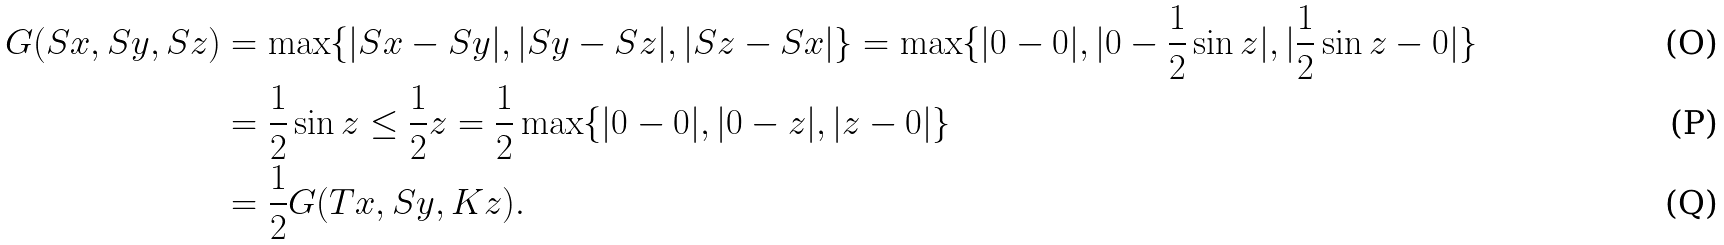<formula> <loc_0><loc_0><loc_500><loc_500>G ( S x , S y , S z ) & = \max \{ | S x - S y | , | S y - S z | , | S z - S x | \} = \max \{ | 0 - 0 | , | 0 - \frac { 1 } { 2 } \sin z | , | \frac { 1 } { 2 } \sin z - 0 | \} \\ & = \frac { 1 } { 2 } \sin z \leq \frac { 1 } { 2 } z = \frac { 1 } { 2 } \max \{ | 0 - 0 | , | 0 - z | , | z - 0 | \} \\ & = \frac { 1 } { 2 } G ( T x , S y , K z ) .</formula> 